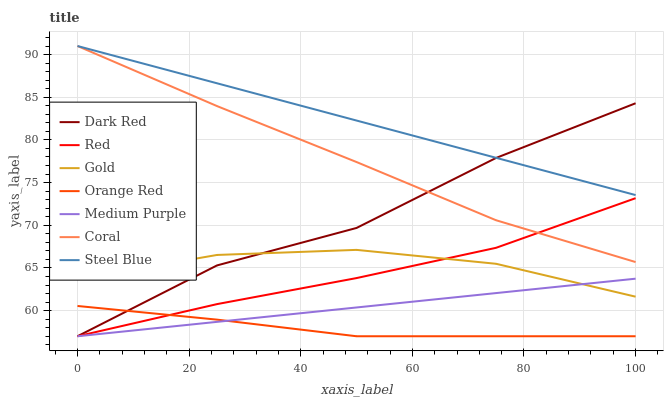Does Orange Red have the minimum area under the curve?
Answer yes or no. Yes. Does Steel Blue have the maximum area under the curve?
Answer yes or no. Yes. Does Dark Red have the minimum area under the curve?
Answer yes or no. No. Does Dark Red have the maximum area under the curve?
Answer yes or no. No. Is Medium Purple the smoothest?
Answer yes or no. Yes. Is Dark Red the roughest?
Answer yes or no. Yes. Is Coral the smoothest?
Answer yes or no. No. Is Coral the roughest?
Answer yes or no. No. Does Dark Red have the lowest value?
Answer yes or no. Yes. Does Coral have the lowest value?
Answer yes or no. No. Does Steel Blue have the highest value?
Answer yes or no. Yes. Does Dark Red have the highest value?
Answer yes or no. No. Is Orange Red less than Steel Blue?
Answer yes or no. Yes. Is Coral greater than Gold?
Answer yes or no. Yes. Does Red intersect Dark Red?
Answer yes or no. Yes. Is Red less than Dark Red?
Answer yes or no. No. Is Red greater than Dark Red?
Answer yes or no. No. Does Orange Red intersect Steel Blue?
Answer yes or no. No. 